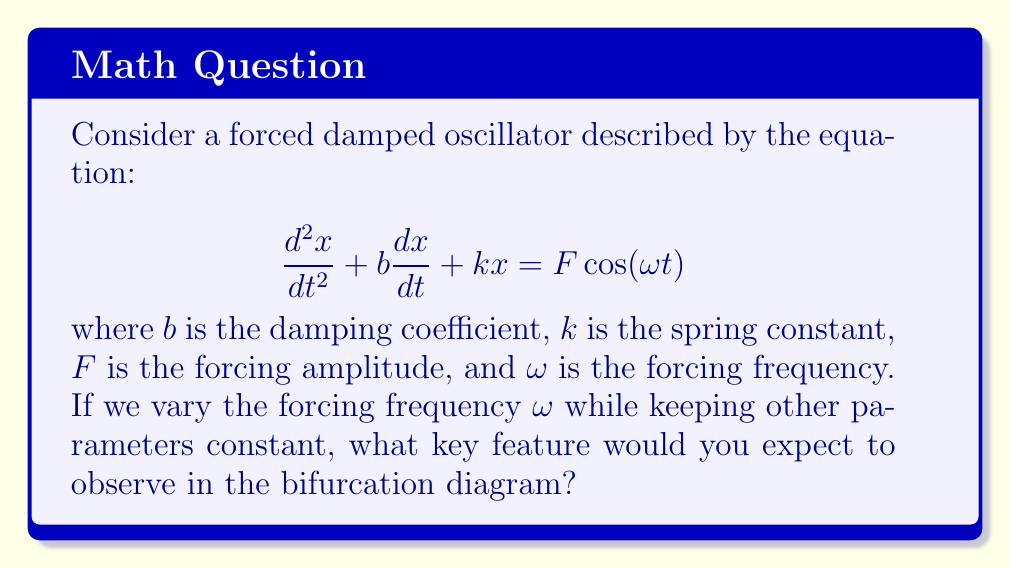Can you answer this question? To understand the bifurcation diagram of this forced damped oscillator, let's break it down step-by-step:

1) The equation describes a second-order differential equation for a forced damped harmonic oscillator.

2) In a bifurcation diagram, we typically plot a system parameter (in this case, $\omega$) on the x-axis and the long-term behavior of the system on the y-axis.

3) For low forcing frequencies, the system will oscillate with the same frequency as the forcing term, but with a phase lag.

4) As we increase $\omega$, the amplitude of oscillation will generally increase.

5) When $\omega$ approaches the natural frequency of the system ($\omega_n = \sqrt{k/m}$, where $m$ is the mass), we expect to see resonance.

6) At resonance, the amplitude of oscillation reaches a maximum.

7) After passing through resonance, the amplitude will decrease as $\omega$ continues to increase.

8) The key feature in this bifurcation diagram would be a peak in the amplitude of oscillation when $\omega$ is near the natural frequency of the system.

9) This peak represents the resonance phenomenon, where the system's response is maximized.

10) The exact shape of this peak depends on the damping coefficient $b$. A lower $b$ will result in a sharper, higher peak, while a higher $b$ will lead to a broader, lower peak.

Therefore, the most notable feature in the bifurcation diagram would be a resonance peak.
Answer: Resonance peak 